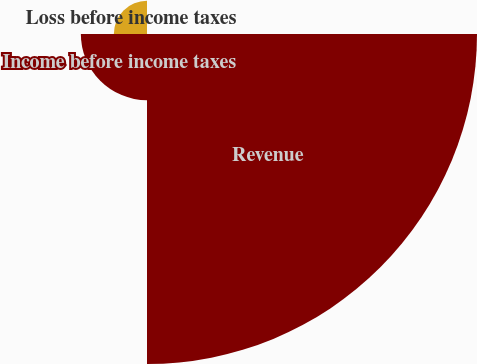<chart> <loc_0><loc_0><loc_500><loc_500><pie_chart><fcel>(In thousands)<fcel>Revenue<fcel>Income before income taxes<fcel>Loss before income taxes<nl><fcel>0.04%<fcel>76.83%<fcel>15.4%<fcel>7.72%<nl></chart> 